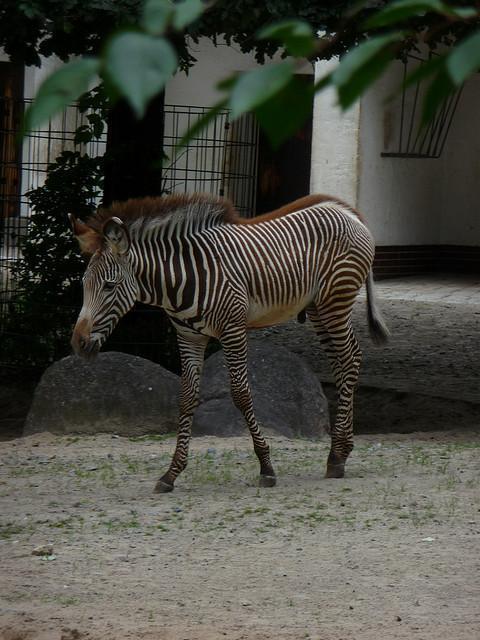How many zebras are pictured?
Give a very brief answer. 1. How many zebras are there in the picture?
Give a very brief answer. 1. 